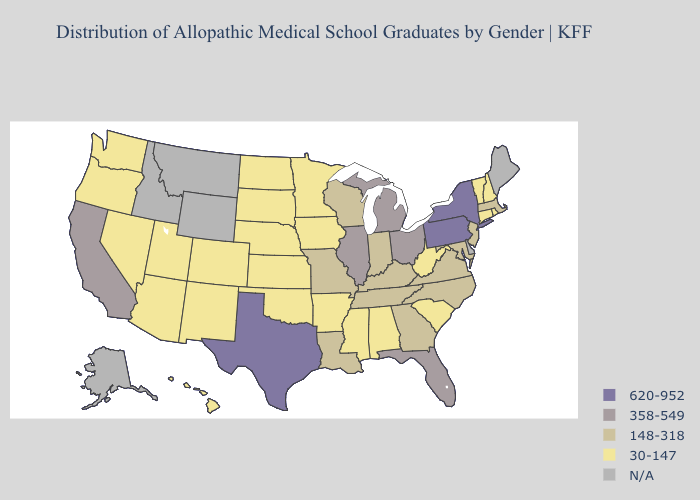Name the states that have a value in the range 358-549?
Quick response, please. California, Florida, Illinois, Michigan, Ohio. Name the states that have a value in the range 358-549?
Answer briefly. California, Florida, Illinois, Michigan, Ohio. Does Texas have the highest value in the South?
Give a very brief answer. Yes. What is the value of Connecticut?
Concise answer only. 30-147. What is the lowest value in the West?
Concise answer only. 30-147. Name the states that have a value in the range N/A?
Short answer required. Alaska, Delaware, Idaho, Maine, Montana, Wyoming. Which states hav the highest value in the Northeast?
Write a very short answer. New York, Pennsylvania. What is the value of Idaho?
Keep it brief. N/A. Name the states that have a value in the range 148-318?
Concise answer only. Georgia, Indiana, Kentucky, Louisiana, Maryland, Massachusetts, Missouri, New Jersey, North Carolina, Tennessee, Virginia, Wisconsin. What is the lowest value in states that border Virginia?
Short answer required. 30-147. Does the map have missing data?
Answer briefly. Yes. Name the states that have a value in the range N/A?
Short answer required. Alaska, Delaware, Idaho, Maine, Montana, Wyoming. Name the states that have a value in the range 30-147?
Write a very short answer. Alabama, Arizona, Arkansas, Colorado, Connecticut, Hawaii, Iowa, Kansas, Minnesota, Mississippi, Nebraska, Nevada, New Hampshire, New Mexico, North Dakota, Oklahoma, Oregon, Rhode Island, South Carolina, South Dakota, Utah, Vermont, Washington, West Virginia. What is the lowest value in the MidWest?
Short answer required. 30-147. 